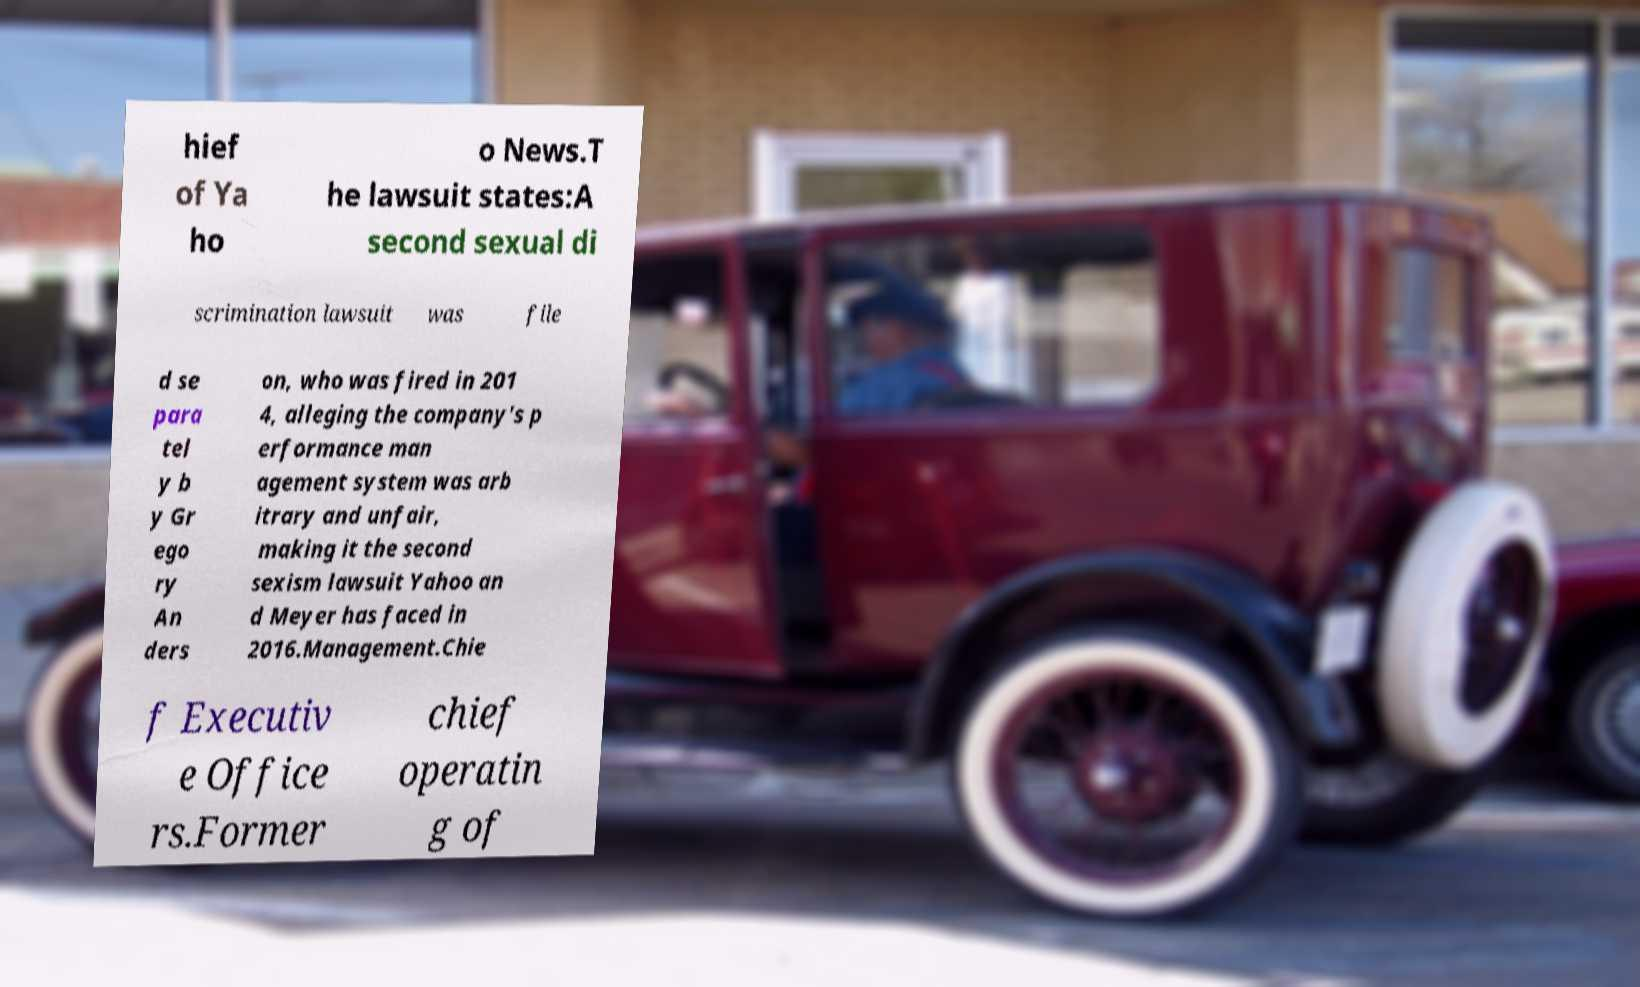Please identify and transcribe the text found in this image. hief of Ya ho o News.T he lawsuit states:A second sexual di scrimination lawsuit was file d se para tel y b y Gr ego ry An ders on, who was fired in 201 4, alleging the company's p erformance man agement system was arb itrary and unfair, making it the second sexism lawsuit Yahoo an d Meyer has faced in 2016.Management.Chie f Executiv e Office rs.Former chief operatin g of 